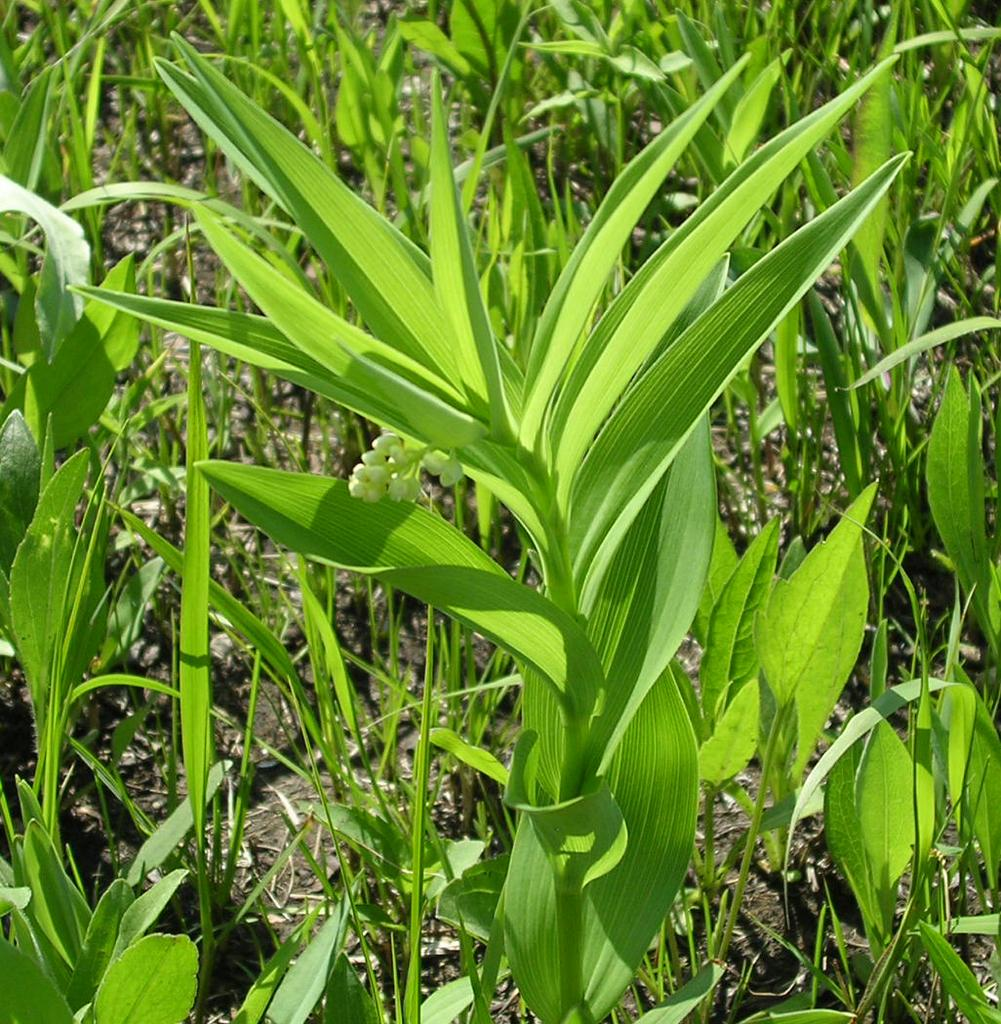What type of landscape is depicted in the image? The image contains farmland. What can be seen growing in the farmland? There are plants in the image. What natural phenomenon is visible at the bottom of the image? Waves are visible at the bottom of the image. What type of loaf is being prepared in the image? There is no loaf or any indication of food preparation in the image. 